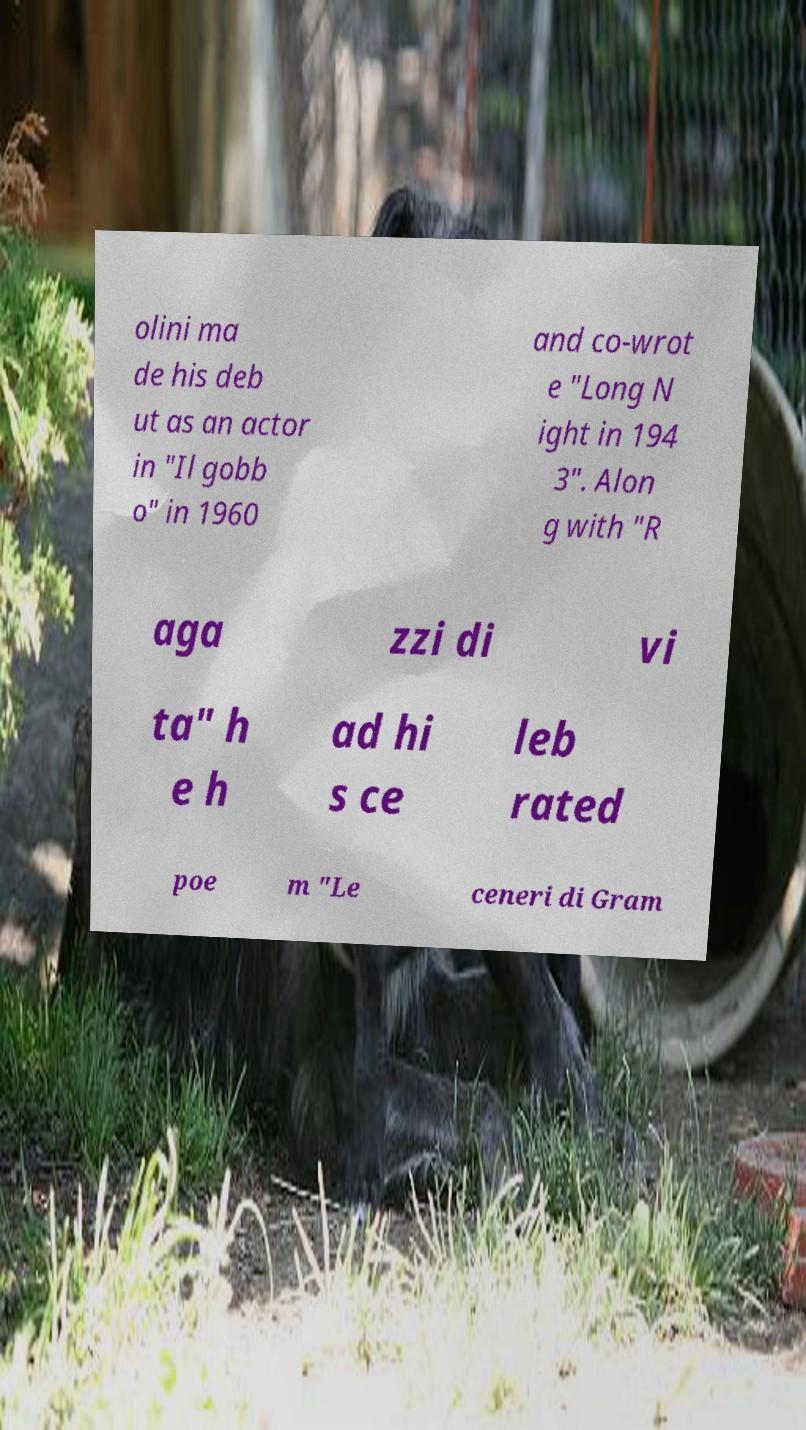What messages or text are displayed in this image? I need them in a readable, typed format. olini ma de his deb ut as an actor in "Il gobb o" in 1960 and co-wrot e "Long N ight in 194 3". Alon g with "R aga zzi di vi ta" h e h ad hi s ce leb rated poe m "Le ceneri di Gram 